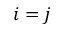Convert formula to latex. <formula><loc_0><loc_0><loc_500><loc_500>i = j</formula> 